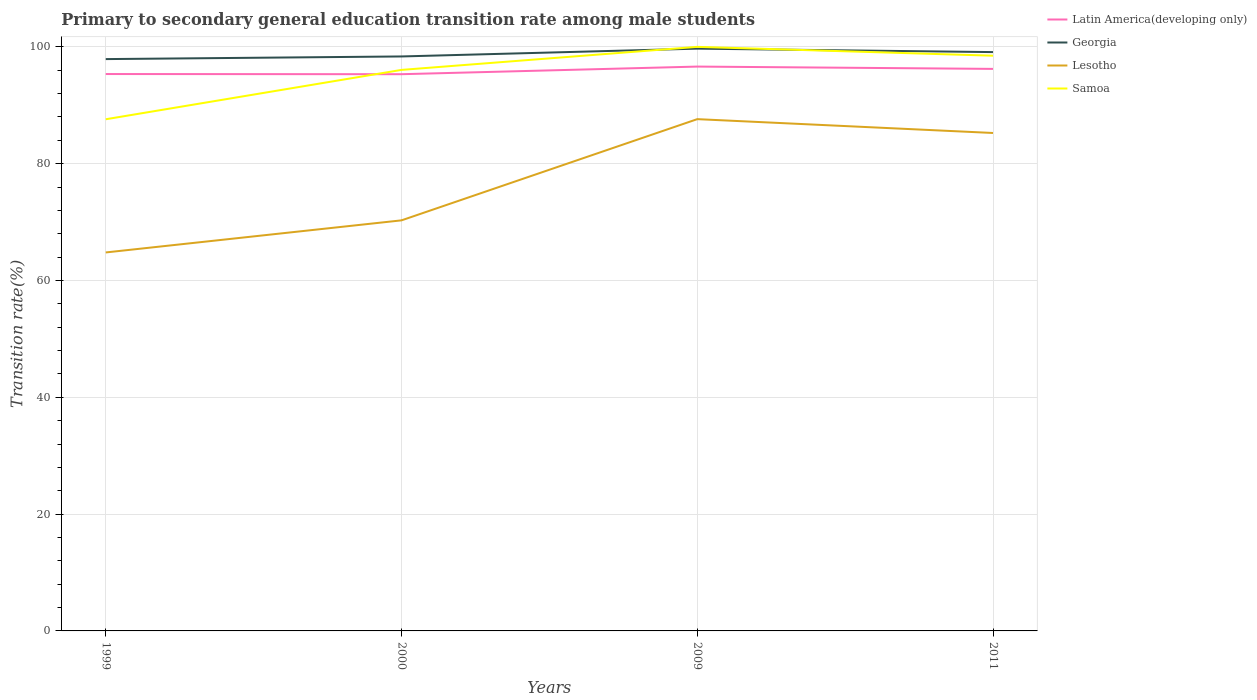Does the line corresponding to Lesotho intersect with the line corresponding to Samoa?
Make the answer very short. No. Across all years, what is the maximum transition rate in Lesotho?
Offer a terse response. 64.8. In which year was the transition rate in Samoa maximum?
Ensure brevity in your answer.  1999. What is the total transition rate in Lesotho in the graph?
Ensure brevity in your answer.  -17.33. What is the difference between the highest and the second highest transition rate in Georgia?
Offer a very short reply. 1.79. Is the transition rate in Latin America(developing only) strictly greater than the transition rate in Samoa over the years?
Make the answer very short. No. How many years are there in the graph?
Keep it short and to the point. 4. Are the values on the major ticks of Y-axis written in scientific E-notation?
Keep it short and to the point. No. Does the graph contain grids?
Your answer should be compact. Yes. What is the title of the graph?
Your answer should be very brief. Primary to secondary general education transition rate among male students. Does "Seychelles" appear as one of the legend labels in the graph?
Give a very brief answer. No. What is the label or title of the X-axis?
Your response must be concise. Years. What is the label or title of the Y-axis?
Provide a succinct answer. Transition rate(%). What is the Transition rate(%) in Latin America(developing only) in 1999?
Your answer should be very brief. 95.35. What is the Transition rate(%) of Georgia in 1999?
Keep it short and to the point. 97.91. What is the Transition rate(%) in Lesotho in 1999?
Your answer should be compact. 64.8. What is the Transition rate(%) of Samoa in 1999?
Offer a very short reply. 87.6. What is the Transition rate(%) of Latin America(developing only) in 2000?
Your response must be concise. 95.32. What is the Transition rate(%) of Georgia in 2000?
Ensure brevity in your answer.  98.36. What is the Transition rate(%) of Lesotho in 2000?
Make the answer very short. 70.3. What is the Transition rate(%) in Samoa in 2000?
Keep it short and to the point. 96.06. What is the Transition rate(%) in Latin America(developing only) in 2009?
Your answer should be very brief. 96.62. What is the Transition rate(%) in Georgia in 2009?
Provide a short and direct response. 99.69. What is the Transition rate(%) in Lesotho in 2009?
Your response must be concise. 87.62. What is the Transition rate(%) of Latin America(developing only) in 2011?
Keep it short and to the point. 96.23. What is the Transition rate(%) of Georgia in 2011?
Your answer should be very brief. 99.1. What is the Transition rate(%) of Lesotho in 2011?
Your answer should be compact. 85.25. What is the Transition rate(%) of Samoa in 2011?
Offer a very short reply. 98.48. Across all years, what is the maximum Transition rate(%) of Latin America(developing only)?
Your answer should be compact. 96.62. Across all years, what is the maximum Transition rate(%) in Georgia?
Give a very brief answer. 99.69. Across all years, what is the maximum Transition rate(%) of Lesotho?
Offer a terse response. 87.62. Across all years, what is the maximum Transition rate(%) in Samoa?
Offer a terse response. 100. Across all years, what is the minimum Transition rate(%) of Latin America(developing only)?
Provide a short and direct response. 95.32. Across all years, what is the minimum Transition rate(%) of Georgia?
Make the answer very short. 97.91. Across all years, what is the minimum Transition rate(%) in Lesotho?
Provide a succinct answer. 64.8. Across all years, what is the minimum Transition rate(%) of Samoa?
Your answer should be very brief. 87.6. What is the total Transition rate(%) in Latin America(developing only) in the graph?
Your response must be concise. 383.52. What is the total Transition rate(%) of Georgia in the graph?
Offer a very short reply. 395.06. What is the total Transition rate(%) in Lesotho in the graph?
Provide a short and direct response. 307.97. What is the total Transition rate(%) in Samoa in the graph?
Provide a short and direct response. 382.14. What is the difference between the Transition rate(%) of Latin America(developing only) in 1999 and that in 2000?
Your response must be concise. 0.03. What is the difference between the Transition rate(%) in Georgia in 1999 and that in 2000?
Offer a terse response. -0.45. What is the difference between the Transition rate(%) in Lesotho in 1999 and that in 2000?
Give a very brief answer. -5.49. What is the difference between the Transition rate(%) in Samoa in 1999 and that in 2000?
Provide a succinct answer. -8.45. What is the difference between the Transition rate(%) of Latin America(developing only) in 1999 and that in 2009?
Make the answer very short. -1.27. What is the difference between the Transition rate(%) of Georgia in 1999 and that in 2009?
Your response must be concise. -1.79. What is the difference between the Transition rate(%) in Lesotho in 1999 and that in 2009?
Your answer should be compact. -22.82. What is the difference between the Transition rate(%) in Samoa in 1999 and that in 2009?
Your answer should be very brief. -12.4. What is the difference between the Transition rate(%) of Latin America(developing only) in 1999 and that in 2011?
Ensure brevity in your answer.  -0.88. What is the difference between the Transition rate(%) in Georgia in 1999 and that in 2011?
Give a very brief answer. -1.2. What is the difference between the Transition rate(%) of Lesotho in 1999 and that in 2011?
Your answer should be compact. -20.45. What is the difference between the Transition rate(%) of Samoa in 1999 and that in 2011?
Offer a terse response. -10.88. What is the difference between the Transition rate(%) of Latin America(developing only) in 2000 and that in 2009?
Make the answer very short. -1.3. What is the difference between the Transition rate(%) in Georgia in 2000 and that in 2009?
Provide a succinct answer. -1.34. What is the difference between the Transition rate(%) in Lesotho in 2000 and that in 2009?
Your answer should be compact. -17.33. What is the difference between the Transition rate(%) of Samoa in 2000 and that in 2009?
Your answer should be compact. -3.94. What is the difference between the Transition rate(%) in Latin America(developing only) in 2000 and that in 2011?
Ensure brevity in your answer.  -0.91. What is the difference between the Transition rate(%) in Georgia in 2000 and that in 2011?
Ensure brevity in your answer.  -0.74. What is the difference between the Transition rate(%) of Lesotho in 2000 and that in 2011?
Offer a terse response. -14.96. What is the difference between the Transition rate(%) in Samoa in 2000 and that in 2011?
Keep it short and to the point. -2.43. What is the difference between the Transition rate(%) of Latin America(developing only) in 2009 and that in 2011?
Provide a short and direct response. 0.39. What is the difference between the Transition rate(%) in Georgia in 2009 and that in 2011?
Ensure brevity in your answer.  0.59. What is the difference between the Transition rate(%) of Lesotho in 2009 and that in 2011?
Provide a short and direct response. 2.37. What is the difference between the Transition rate(%) in Samoa in 2009 and that in 2011?
Your response must be concise. 1.52. What is the difference between the Transition rate(%) of Latin America(developing only) in 1999 and the Transition rate(%) of Georgia in 2000?
Keep it short and to the point. -3.01. What is the difference between the Transition rate(%) in Latin America(developing only) in 1999 and the Transition rate(%) in Lesotho in 2000?
Give a very brief answer. 25.05. What is the difference between the Transition rate(%) in Latin America(developing only) in 1999 and the Transition rate(%) in Samoa in 2000?
Offer a very short reply. -0.71. What is the difference between the Transition rate(%) of Georgia in 1999 and the Transition rate(%) of Lesotho in 2000?
Provide a short and direct response. 27.61. What is the difference between the Transition rate(%) of Georgia in 1999 and the Transition rate(%) of Samoa in 2000?
Keep it short and to the point. 1.85. What is the difference between the Transition rate(%) in Lesotho in 1999 and the Transition rate(%) in Samoa in 2000?
Offer a very short reply. -31.25. What is the difference between the Transition rate(%) of Latin America(developing only) in 1999 and the Transition rate(%) of Georgia in 2009?
Your answer should be compact. -4.35. What is the difference between the Transition rate(%) of Latin America(developing only) in 1999 and the Transition rate(%) of Lesotho in 2009?
Offer a terse response. 7.73. What is the difference between the Transition rate(%) in Latin America(developing only) in 1999 and the Transition rate(%) in Samoa in 2009?
Make the answer very short. -4.65. What is the difference between the Transition rate(%) of Georgia in 1999 and the Transition rate(%) of Lesotho in 2009?
Give a very brief answer. 10.28. What is the difference between the Transition rate(%) in Georgia in 1999 and the Transition rate(%) in Samoa in 2009?
Provide a short and direct response. -2.09. What is the difference between the Transition rate(%) in Lesotho in 1999 and the Transition rate(%) in Samoa in 2009?
Your response must be concise. -35.2. What is the difference between the Transition rate(%) of Latin America(developing only) in 1999 and the Transition rate(%) of Georgia in 2011?
Provide a succinct answer. -3.75. What is the difference between the Transition rate(%) in Latin America(developing only) in 1999 and the Transition rate(%) in Lesotho in 2011?
Offer a terse response. 10.09. What is the difference between the Transition rate(%) of Latin America(developing only) in 1999 and the Transition rate(%) of Samoa in 2011?
Your answer should be very brief. -3.14. What is the difference between the Transition rate(%) of Georgia in 1999 and the Transition rate(%) of Lesotho in 2011?
Offer a terse response. 12.65. What is the difference between the Transition rate(%) of Georgia in 1999 and the Transition rate(%) of Samoa in 2011?
Your response must be concise. -0.58. What is the difference between the Transition rate(%) of Lesotho in 1999 and the Transition rate(%) of Samoa in 2011?
Your answer should be very brief. -33.68. What is the difference between the Transition rate(%) of Latin America(developing only) in 2000 and the Transition rate(%) of Georgia in 2009?
Ensure brevity in your answer.  -4.38. What is the difference between the Transition rate(%) of Latin America(developing only) in 2000 and the Transition rate(%) of Lesotho in 2009?
Provide a succinct answer. 7.7. What is the difference between the Transition rate(%) in Latin America(developing only) in 2000 and the Transition rate(%) in Samoa in 2009?
Ensure brevity in your answer.  -4.68. What is the difference between the Transition rate(%) of Georgia in 2000 and the Transition rate(%) of Lesotho in 2009?
Your response must be concise. 10.74. What is the difference between the Transition rate(%) in Georgia in 2000 and the Transition rate(%) in Samoa in 2009?
Keep it short and to the point. -1.64. What is the difference between the Transition rate(%) of Lesotho in 2000 and the Transition rate(%) of Samoa in 2009?
Give a very brief answer. -29.7. What is the difference between the Transition rate(%) in Latin America(developing only) in 2000 and the Transition rate(%) in Georgia in 2011?
Your answer should be very brief. -3.78. What is the difference between the Transition rate(%) in Latin America(developing only) in 2000 and the Transition rate(%) in Lesotho in 2011?
Offer a very short reply. 10.07. What is the difference between the Transition rate(%) in Latin America(developing only) in 2000 and the Transition rate(%) in Samoa in 2011?
Offer a terse response. -3.17. What is the difference between the Transition rate(%) in Georgia in 2000 and the Transition rate(%) in Lesotho in 2011?
Your answer should be compact. 13.1. What is the difference between the Transition rate(%) of Georgia in 2000 and the Transition rate(%) of Samoa in 2011?
Your answer should be compact. -0.13. What is the difference between the Transition rate(%) of Lesotho in 2000 and the Transition rate(%) of Samoa in 2011?
Your answer should be compact. -28.19. What is the difference between the Transition rate(%) of Latin America(developing only) in 2009 and the Transition rate(%) of Georgia in 2011?
Provide a short and direct response. -2.48. What is the difference between the Transition rate(%) in Latin America(developing only) in 2009 and the Transition rate(%) in Lesotho in 2011?
Provide a succinct answer. 11.37. What is the difference between the Transition rate(%) in Latin America(developing only) in 2009 and the Transition rate(%) in Samoa in 2011?
Provide a succinct answer. -1.86. What is the difference between the Transition rate(%) in Georgia in 2009 and the Transition rate(%) in Lesotho in 2011?
Give a very brief answer. 14.44. What is the difference between the Transition rate(%) in Georgia in 2009 and the Transition rate(%) in Samoa in 2011?
Make the answer very short. 1.21. What is the difference between the Transition rate(%) in Lesotho in 2009 and the Transition rate(%) in Samoa in 2011?
Offer a very short reply. -10.86. What is the average Transition rate(%) of Latin America(developing only) per year?
Offer a terse response. 95.88. What is the average Transition rate(%) of Georgia per year?
Your response must be concise. 98.76. What is the average Transition rate(%) of Lesotho per year?
Offer a terse response. 76.99. What is the average Transition rate(%) in Samoa per year?
Offer a terse response. 95.54. In the year 1999, what is the difference between the Transition rate(%) of Latin America(developing only) and Transition rate(%) of Georgia?
Your answer should be compact. -2.56. In the year 1999, what is the difference between the Transition rate(%) in Latin America(developing only) and Transition rate(%) in Lesotho?
Provide a succinct answer. 30.55. In the year 1999, what is the difference between the Transition rate(%) in Latin America(developing only) and Transition rate(%) in Samoa?
Offer a terse response. 7.74. In the year 1999, what is the difference between the Transition rate(%) of Georgia and Transition rate(%) of Lesotho?
Your answer should be very brief. 33.1. In the year 1999, what is the difference between the Transition rate(%) in Georgia and Transition rate(%) in Samoa?
Your answer should be very brief. 10.3. In the year 1999, what is the difference between the Transition rate(%) of Lesotho and Transition rate(%) of Samoa?
Your answer should be compact. -22.8. In the year 2000, what is the difference between the Transition rate(%) of Latin America(developing only) and Transition rate(%) of Georgia?
Give a very brief answer. -3.04. In the year 2000, what is the difference between the Transition rate(%) in Latin America(developing only) and Transition rate(%) in Lesotho?
Provide a succinct answer. 25.02. In the year 2000, what is the difference between the Transition rate(%) in Latin America(developing only) and Transition rate(%) in Samoa?
Offer a terse response. -0.74. In the year 2000, what is the difference between the Transition rate(%) in Georgia and Transition rate(%) in Lesotho?
Your answer should be very brief. 28.06. In the year 2000, what is the difference between the Transition rate(%) in Georgia and Transition rate(%) in Samoa?
Your answer should be very brief. 2.3. In the year 2000, what is the difference between the Transition rate(%) of Lesotho and Transition rate(%) of Samoa?
Offer a terse response. -25.76. In the year 2009, what is the difference between the Transition rate(%) of Latin America(developing only) and Transition rate(%) of Georgia?
Offer a terse response. -3.07. In the year 2009, what is the difference between the Transition rate(%) in Latin America(developing only) and Transition rate(%) in Samoa?
Your answer should be compact. -3.38. In the year 2009, what is the difference between the Transition rate(%) of Georgia and Transition rate(%) of Lesotho?
Offer a very short reply. 12.07. In the year 2009, what is the difference between the Transition rate(%) of Georgia and Transition rate(%) of Samoa?
Offer a very short reply. -0.31. In the year 2009, what is the difference between the Transition rate(%) of Lesotho and Transition rate(%) of Samoa?
Make the answer very short. -12.38. In the year 2011, what is the difference between the Transition rate(%) in Latin America(developing only) and Transition rate(%) in Georgia?
Provide a short and direct response. -2.87. In the year 2011, what is the difference between the Transition rate(%) in Latin America(developing only) and Transition rate(%) in Lesotho?
Offer a very short reply. 10.98. In the year 2011, what is the difference between the Transition rate(%) of Latin America(developing only) and Transition rate(%) of Samoa?
Offer a very short reply. -2.26. In the year 2011, what is the difference between the Transition rate(%) of Georgia and Transition rate(%) of Lesotho?
Keep it short and to the point. 13.85. In the year 2011, what is the difference between the Transition rate(%) in Georgia and Transition rate(%) in Samoa?
Ensure brevity in your answer.  0.62. In the year 2011, what is the difference between the Transition rate(%) in Lesotho and Transition rate(%) in Samoa?
Offer a terse response. -13.23. What is the ratio of the Transition rate(%) in Latin America(developing only) in 1999 to that in 2000?
Provide a succinct answer. 1. What is the ratio of the Transition rate(%) of Georgia in 1999 to that in 2000?
Offer a terse response. 1. What is the ratio of the Transition rate(%) of Lesotho in 1999 to that in 2000?
Make the answer very short. 0.92. What is the ratio of the Transition rate(%) of Samoa in 1999 to that in 2000?
Ensure brevity in your answer.  0.91. What is the ratio of the Transition rate(%) of Georgia in 1999 to that in 2009?
Your response must be concise. 0.98. What is the ratio of the Transition rate(%) in Lesotho in 1999 to that in 2009?
Give a very brief answer. 0.74. What is the ratio of the Transition rate(%) of Samoa in 1999 to that in 2009?
Give a very brief answer. 0.88. What is the ratio of the Transition rate(%) in Latin America(developing only) in 1999 to that in 2011?
Your response must be concise. 0.99. What is the ratio of the Transition rate(%) in Georgia in 1999 to that in 2011?
Make the answer very short. 0.99. What is the ratio of the Transition rate(%) in Lesotho in 1999 to that in 2011?
Provide a short and direct response. 0.76. What is the ratio of the Transition rate(%) of Samoa in 1999 to that in 2011?
Make the answer very short. 0.89. What is the ratio of the Transition rate(%) of Latin America(developing only) in 2000 to that in 2009?
Your answer should be very brief. 0.99. What is the ratio of the Transition rate(%) in Georgia in 2000 to that in 2009?
Your answer should be compact. 0.99. What is the ratio of the Transition rate(%) of Lesotho in 2000 to that in 2009?
Provide a succinct answer. 0.8. What is the ratio of the Transition rate(%) of Samoa in 2000 to that in 2009?
Your answer should be very brief. 0.96. What is the ratio of the Transition rate(%) in Latin America(developing only) in 2000 to that in 2011?
Ensure brevity in your answer.  0.99. What is the ratio of the Transition rate(%) in Lesotho in 2000 to that in 2011?
Provide a short and direct response. 0.82. What is the ratio of the Transition rate(%) of Samoa in 2000 to that in 2011?
Offer a very short reply. 0.98. What is the ratio of the Transition rate(%) of Latin America(developing only) in 2009 to that in 2011?
Ensure brevity in your answer.  1. What is the ratio of the Transition rate(%) in Georgia in 2009 to that in 2011?
Provide a short and direct response. 1.01. What is the ratio of the Transition rate(%) in Lesotho in 2009 to that in 2011?
Give a very brief answer. 1.03. What is the ratio of the Transition rate(%) in Samoa in 2009 to that in 2011?
Provide a short and direct response. 1.02. What is the difference between the highest and the second highest Transition rate(%) of Latin America(developing only)?
Keep it short and to the point. 0.39. What is the difference between the highest and the second highest Transition rate(%) of Georgia?
Keep it short and to the point. 0.59. What is the difference between the highest and the second highest Transition rate(%) of Lesotho?
Offer a very short reply. 2.37. What is the difference between the highest and the second highest Transition rate(%) in Samoa?
Make the answer very short. 1.52. What is the difference between the highest and the lowest Transition rate(%) of Latin America(developing only)?
Provide a short and direct response. 1.3. What is the difference between the highest and the lowest Transition rate(%) in Georgia?
Your response must be concise. 1.79. What is the difference between the highest and the lowest Transition rate(%) of Lesotho?
Provide a short and direct response. 22.82. What is the difference between the highest and the lowest Transition rate(%) in Samoa?
Offer a very short reply. 12.4. 